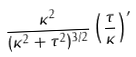Convert formula to latex. <formula><loc_0><loc_0><loc_500><loc_500>\frac { \kappa ^ { 2 } } { ( \kappa ^ { 2 } + \tau ^ { 2 } ) ^ { 3 / 2 } } \left ( \frac { \tau } { \kappa } \right ) ^ { \prime }</formula> 